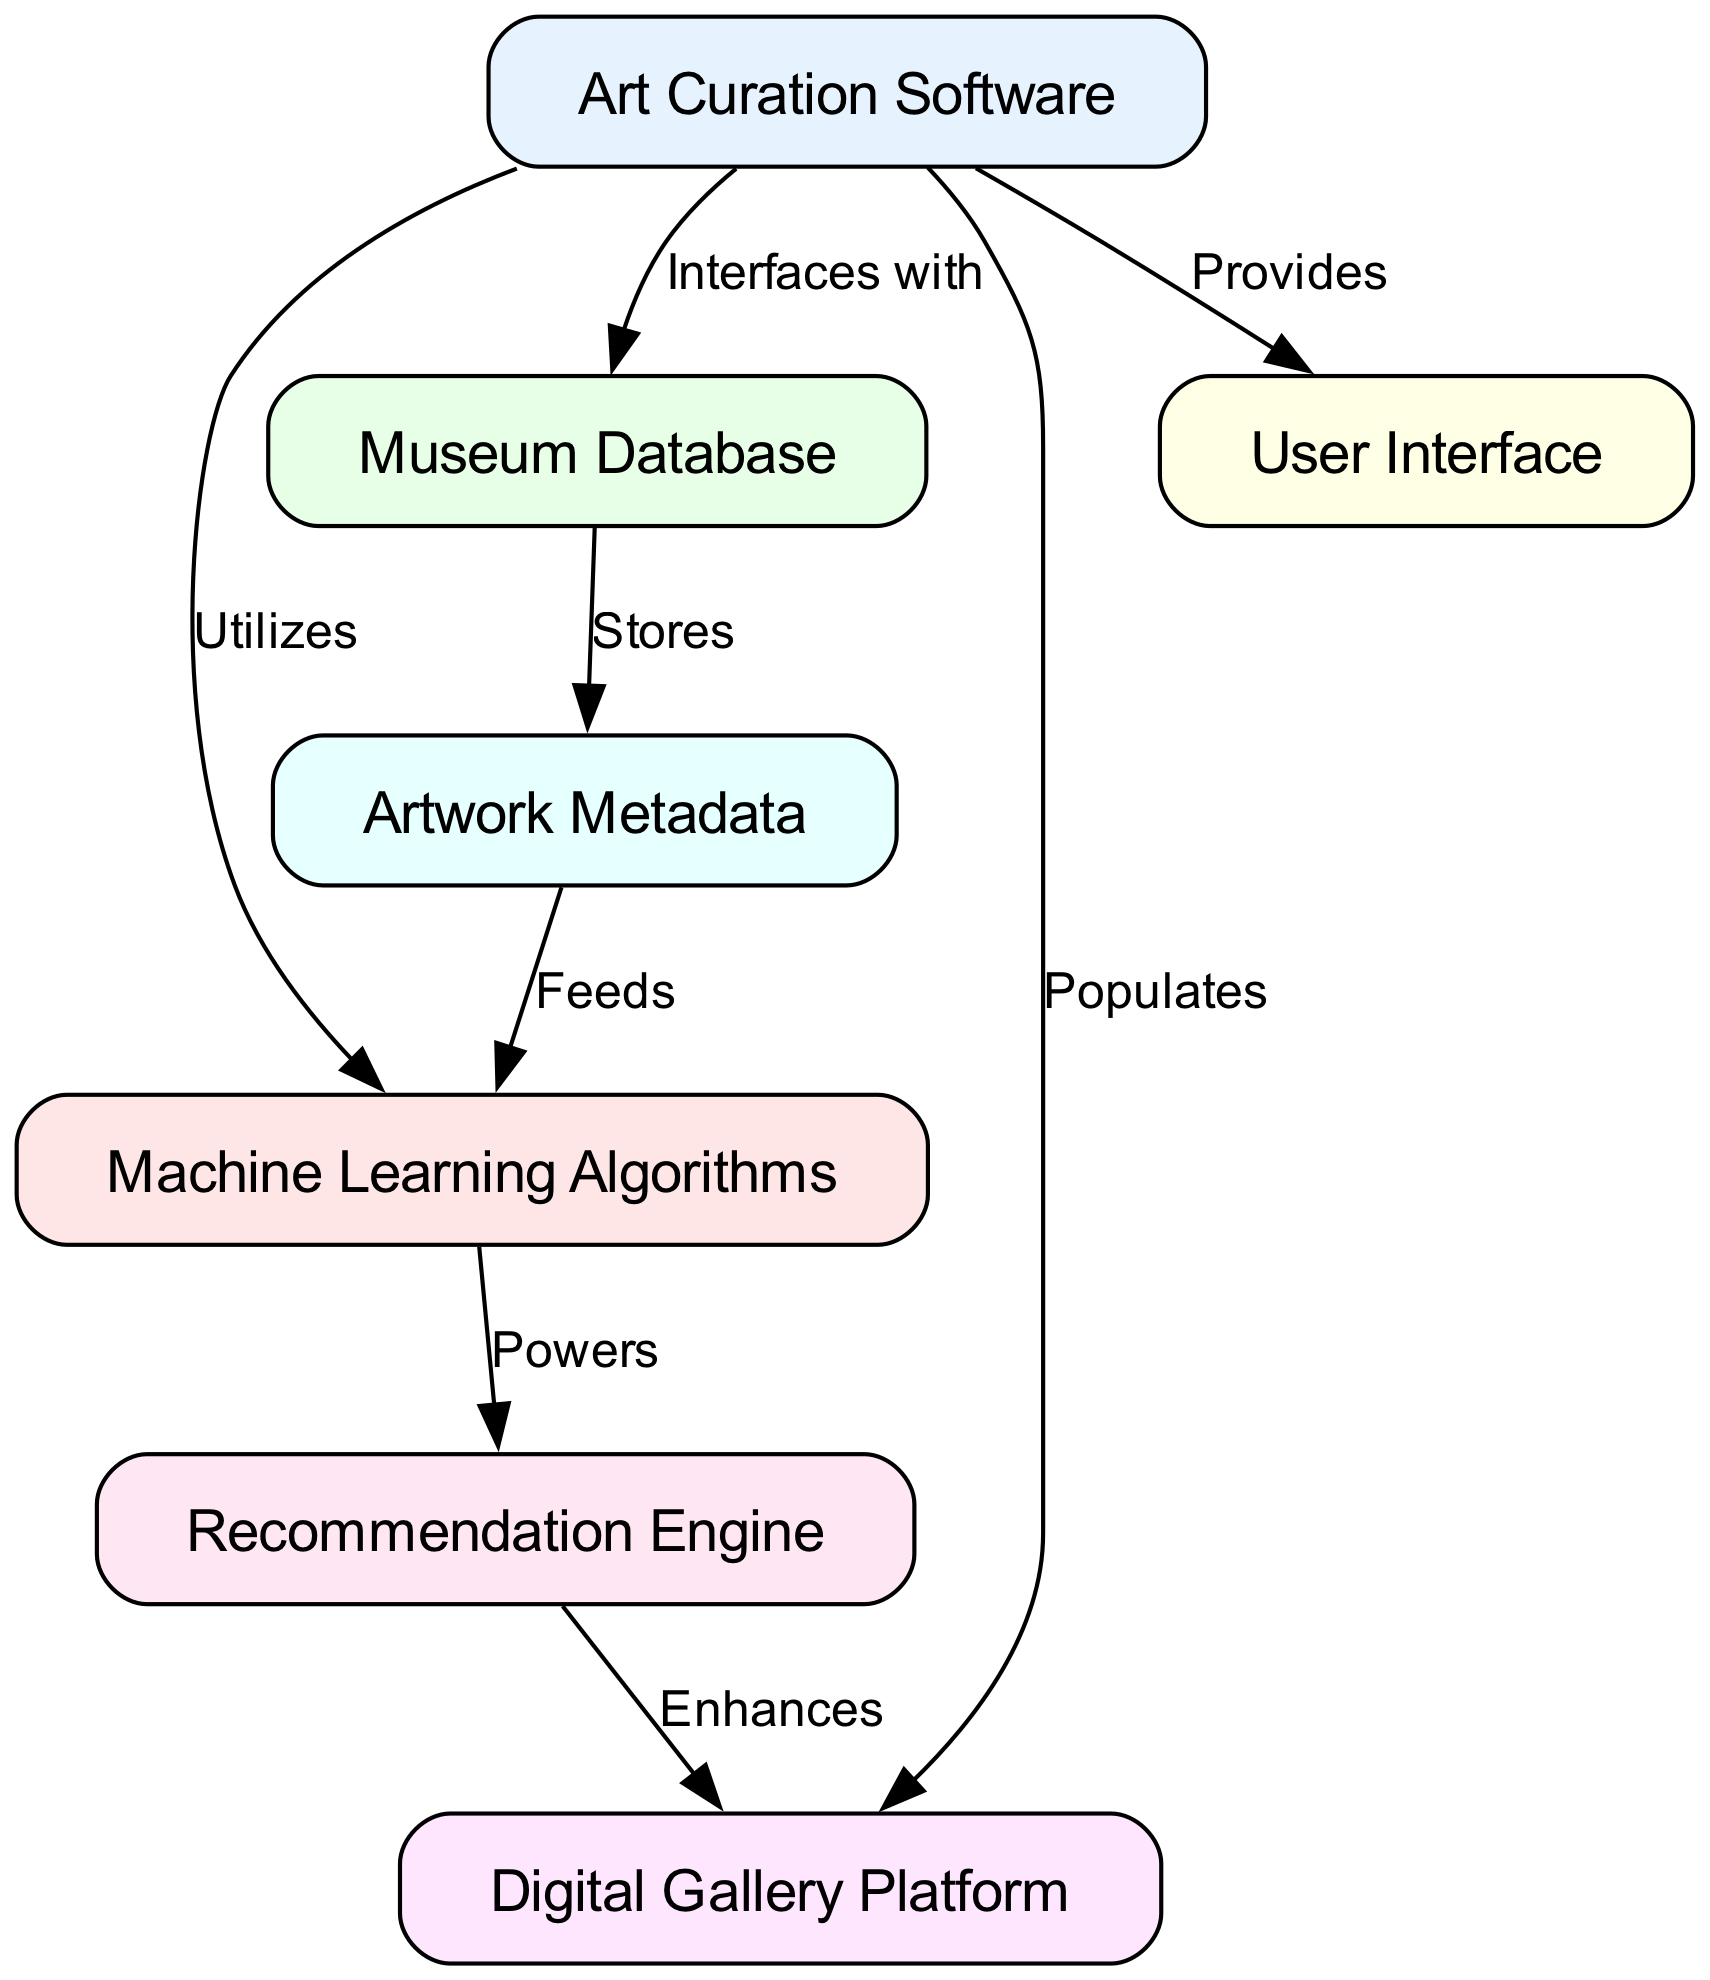What is the total number of nodes in the diagram? The diagram contains nodes for the "Art Curation Software," "Machine Learning Algorithms," "Museum Database," "Digital Gallery Platform," "User Interface," "Artwork Metadata," and "Recommendation Engine." Counting these gives a total of 7 nodes.
Answer: 7 Which node interfaces with the Museum Database? The "Art Curation Software" node is shown to have an edge labeled "Interfaces with," connecting it to the "Museum Database." Therefore, it is the node that interfaces with the Museum Database.
Answer: Art Curation Software What relationship does the Recommendation Engine have with the Digital Gallery Platform? The "Recommendation Engine" has an edge labeled "Enhances" that connects it to the "Digital Gallery Platform." This indicates that the Recommendation Engine enhances the Digital Gallery Platform in some capacity.
Answer: Enhances What feeds the Machine Learning Algorithms? "Artwork Metadata" has an edge labeled "Feeds" that connects to the "Machine Learning Algorithms." This indicates that the data stored in Artwork Metadata is the source feeding into the Machine Learning Algorithms for processing.
Answer: Artwork Metadata How many edges are present in the diagram? By counting the edges in the diagram, we can see there are a total of 8 edges representing the various relationships and interactions between the nodes.
Answer: 8 What is the significance of the link between Art Curation Software and User Interface? The edge labeled "Provides" from "Art Curation Software" to "User Interface" indicates that the Art Curation Software supplies or generates the User Interface, implying that user interaction is facilitated by the features of the curation software.
Answer: Provides Which component powers the Recommendation Engine? The "Machine Learning Algorithms" node has an edge labeled "Powers" connecting it to the "Recommendation Engine." Thus, the Machine Learning Algorithms are the mechanism that powers the Recommendation Engine.
Answer: Machine Learning Algorithms What does the Museum Database store? The diagram states that the "Museum Database" "Stores" "Artwork Metadata," indicating that this database serves to hold information pertaining to the artworks.
Answer: Artwork Metadata 